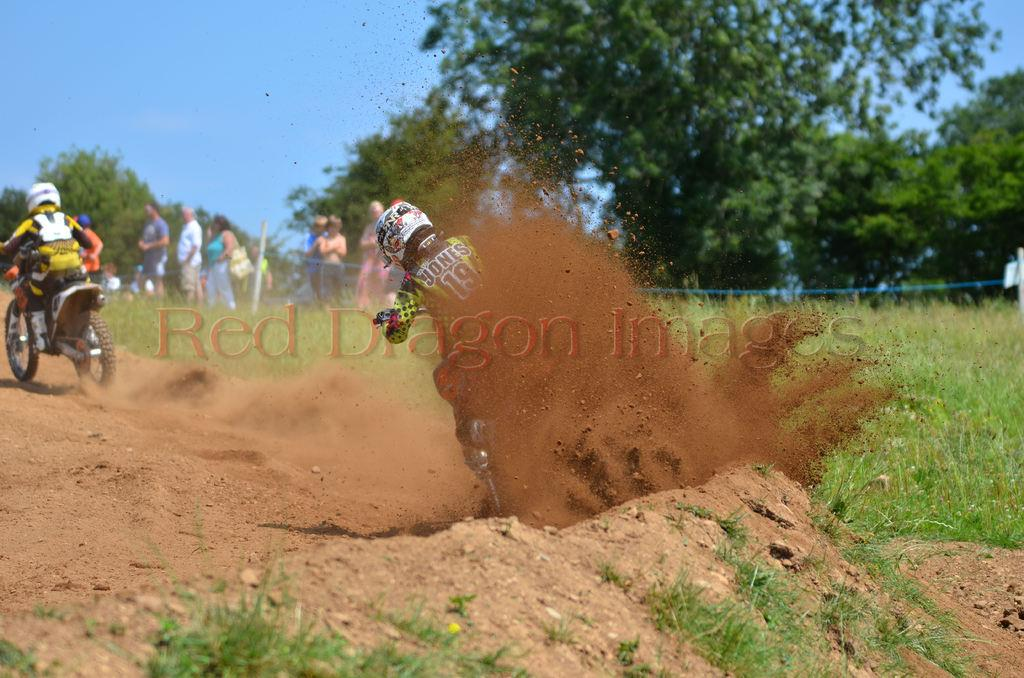What are the two persons in the image doing? The two persons are riding a motorbike in the image. What else can be seen in the image besides the motorbike? There is a group of people standing in the image, as well as a grassy land and many trees. Where is the sink located in the image? There is no sink present in the image. What type of thrill can be experienced by the persons riding the motorbike in the image? The provided facts do not mention any specific thrill or emotion experienced by the persons riding the motorbike. 